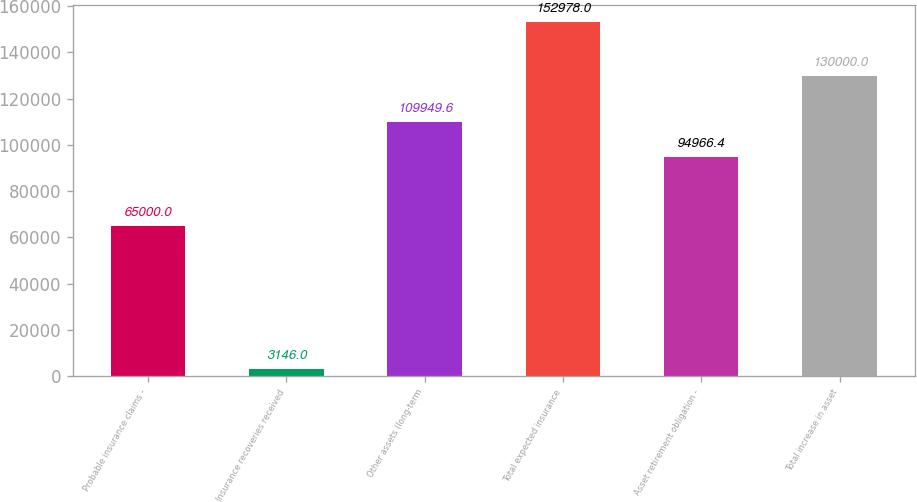Convert chart to OTSL. <chart><loc_0><loc_0><loc_500><loc_500><bar_chart><fcel>Probable insurance claims -<fcel>Insurance recoveries received<fcel>Other assets (long-term<fcel>Total expected insurance<fcel>Asset retirement obligation -<fcel>Total increase in asset<nl><fcel>65000<fcel>3146<fcel>109950<fcel>152978<fcel>94966.4<fcel>130000<nl></chart> 